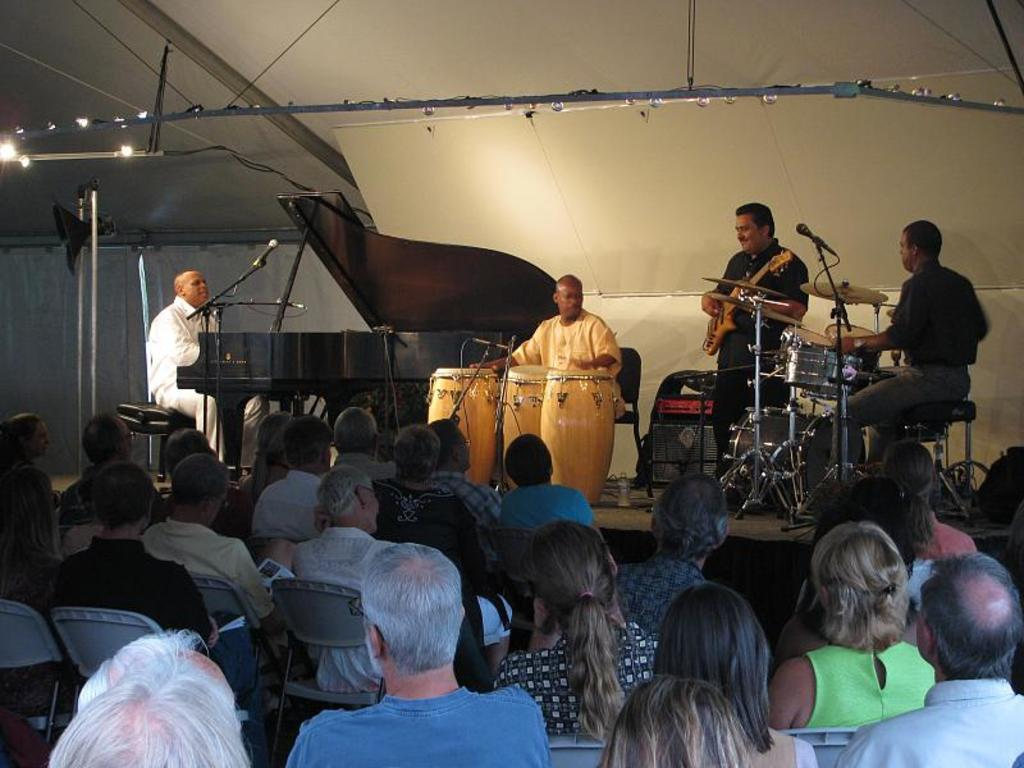What is happening in the image involving a group of people? In the image, a group of people are playing musical instruments. What are the people doing while playing their instruments? Each person is looking at their side. How long does it take for the people to complete their voyage in the image? There is no indication of a voyage or any travel-related activity in the image. The people are simply playing musical instruments and looking at their sides. 